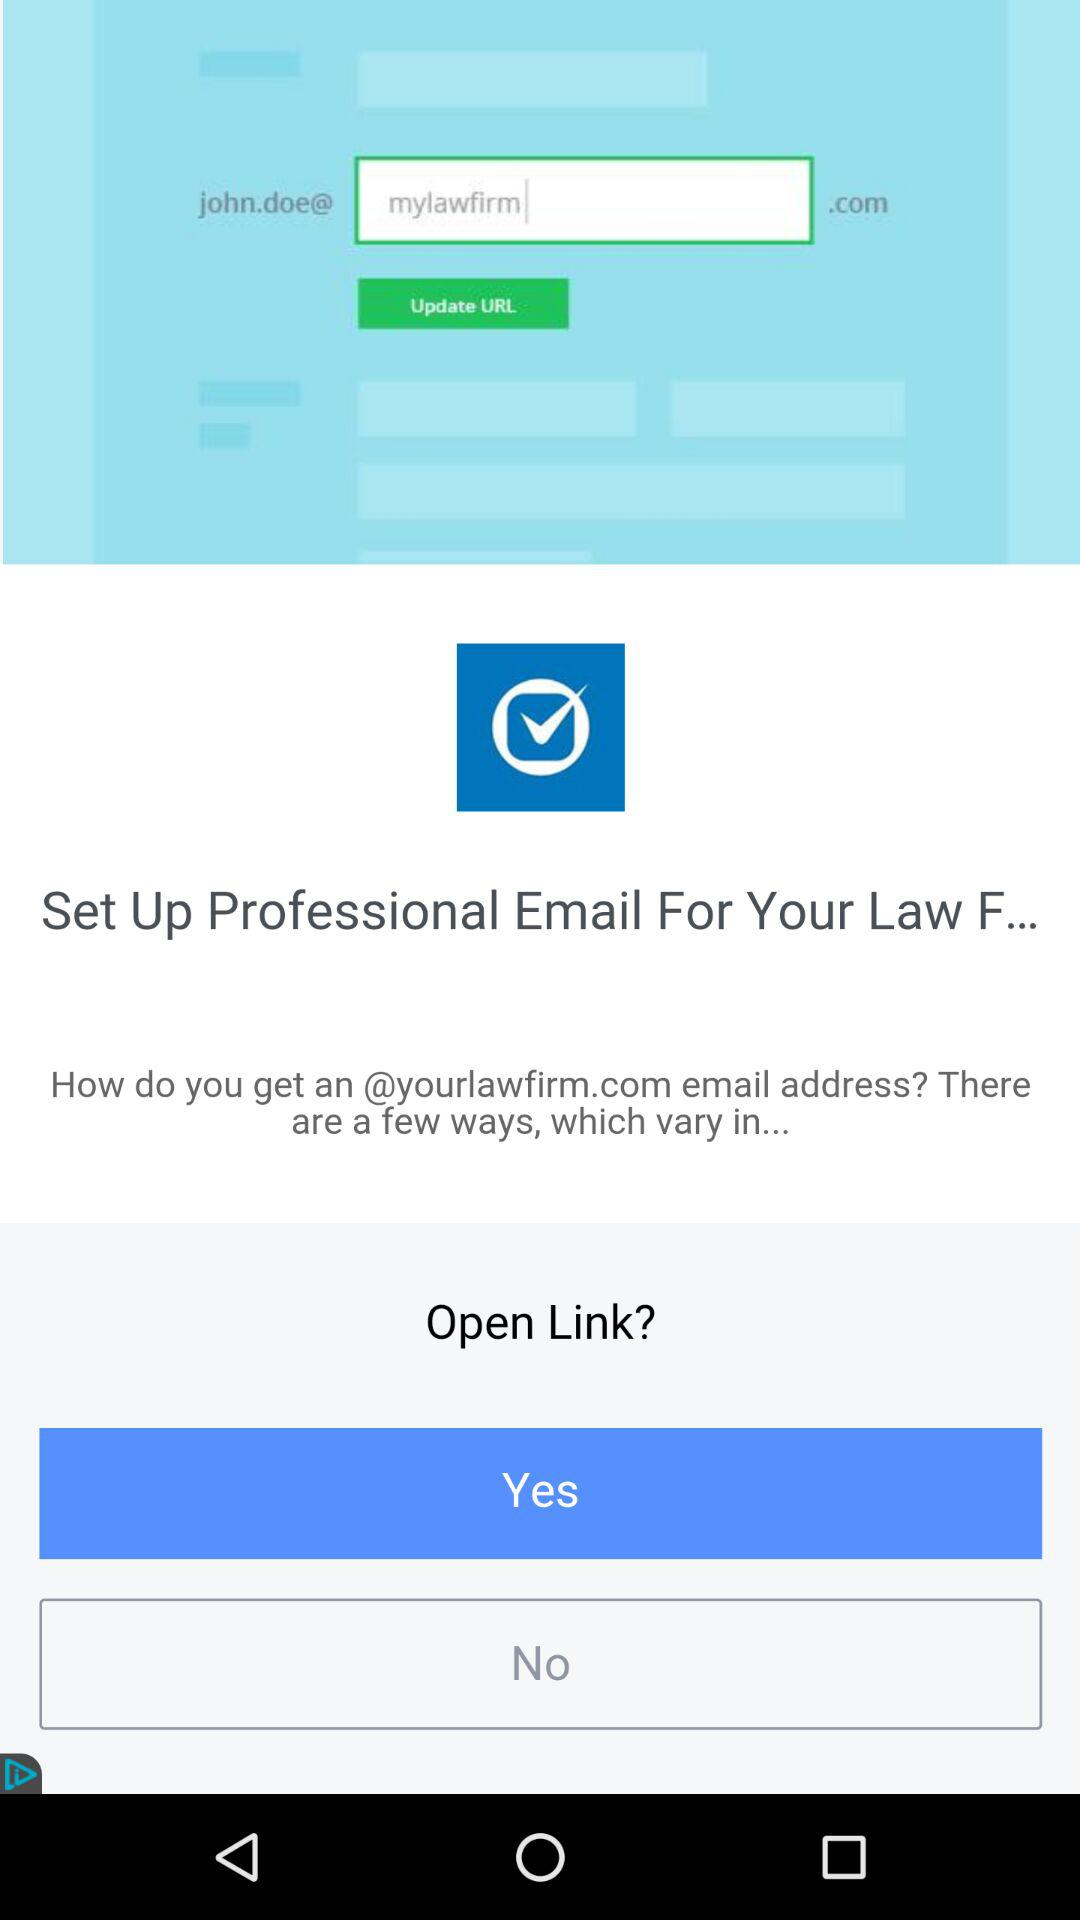How many checkboxes are in the app?
Answer the question using a single word or phrase. 1 